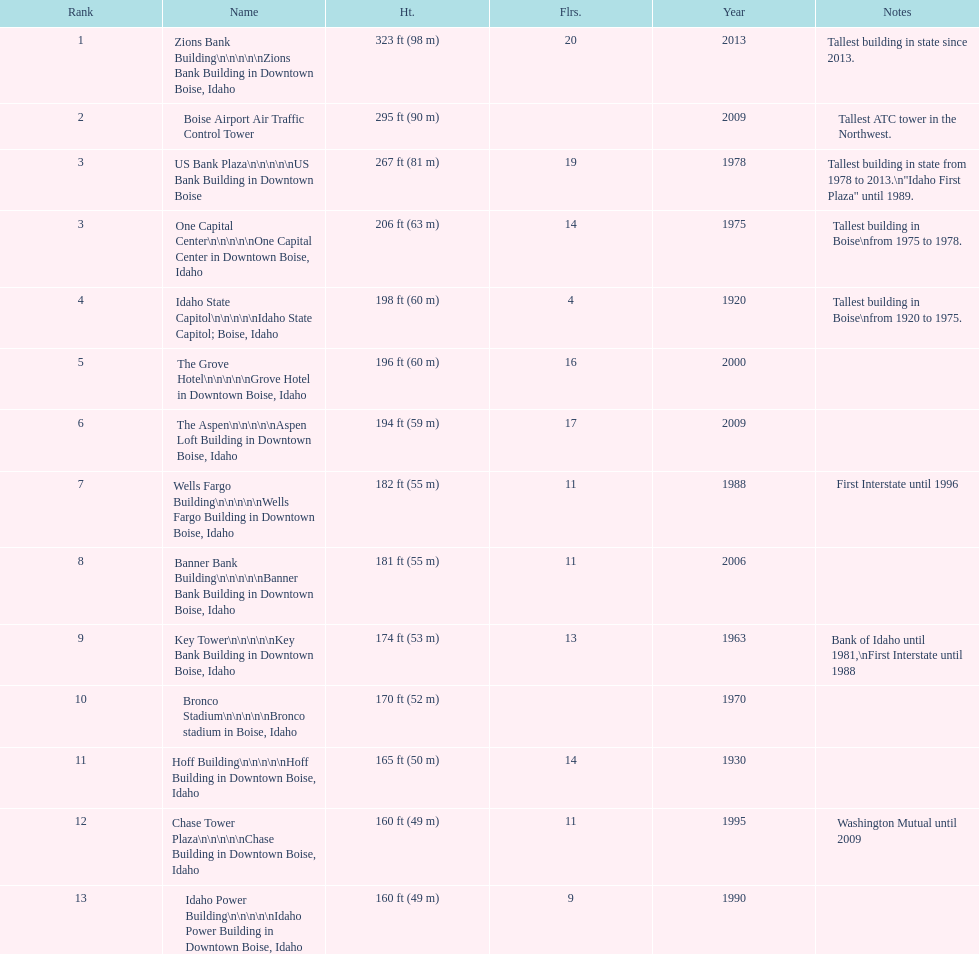What is the tallest building in bosie, idaho? Zions Bank Building Zions Bank Building in Downtown Boise, Idaho. 